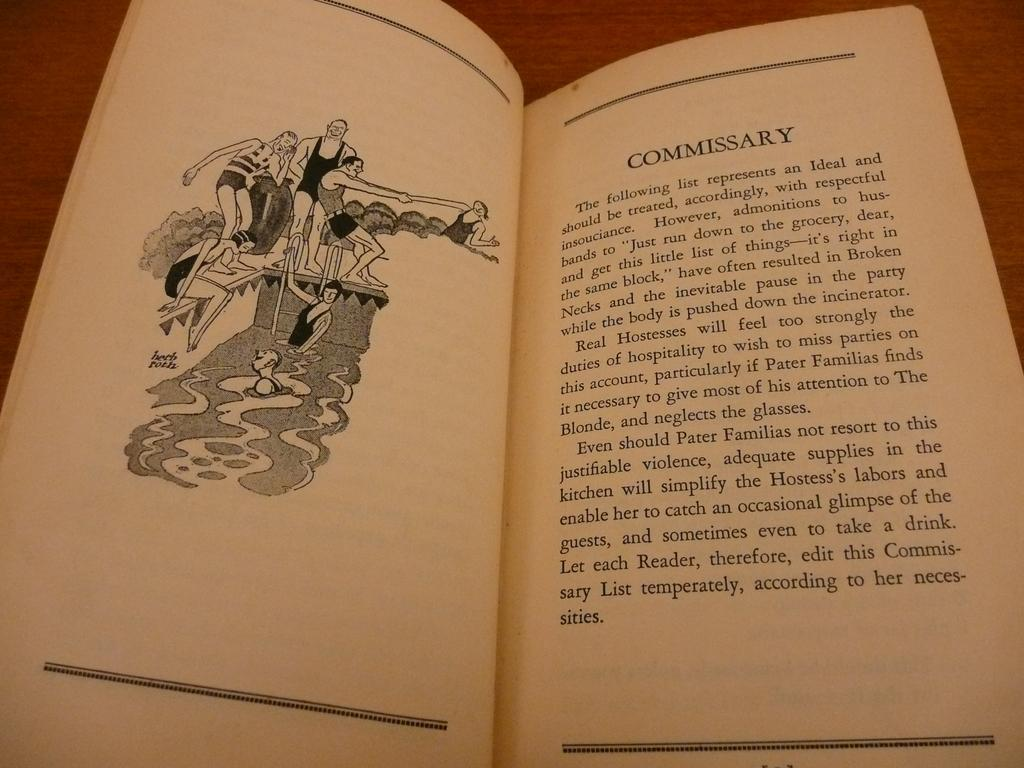<image>
Share a concise interpretation of the image provided. A book is open to a page with a heading that says Commissary. 